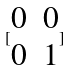Convert formula to latex. <formula><loc_0><loc_0><loc_500><loc_500>[ \begin{matrix} 0 & 0 \\ 0 & 1 \end{matrix} ]</formula> 